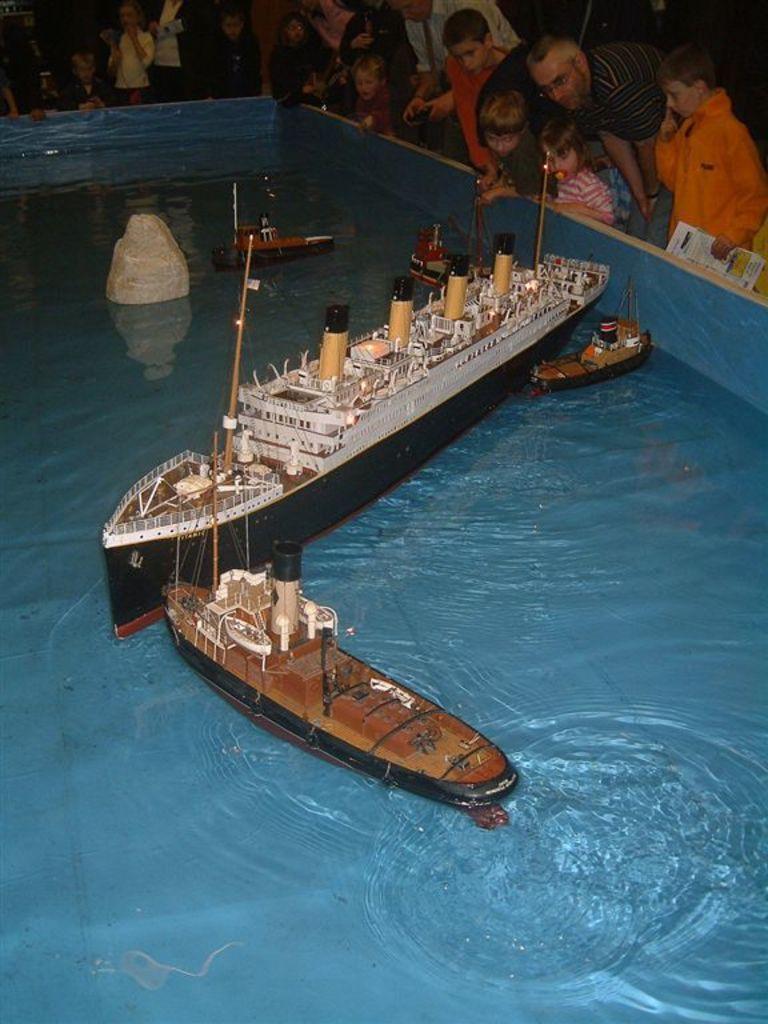Could you give a brief overview of what you see in this image? Here in this picture we can see a pond filled with water and in that we can see miniature ships and boats present and beside that we can see number of people and children standing and watching. 